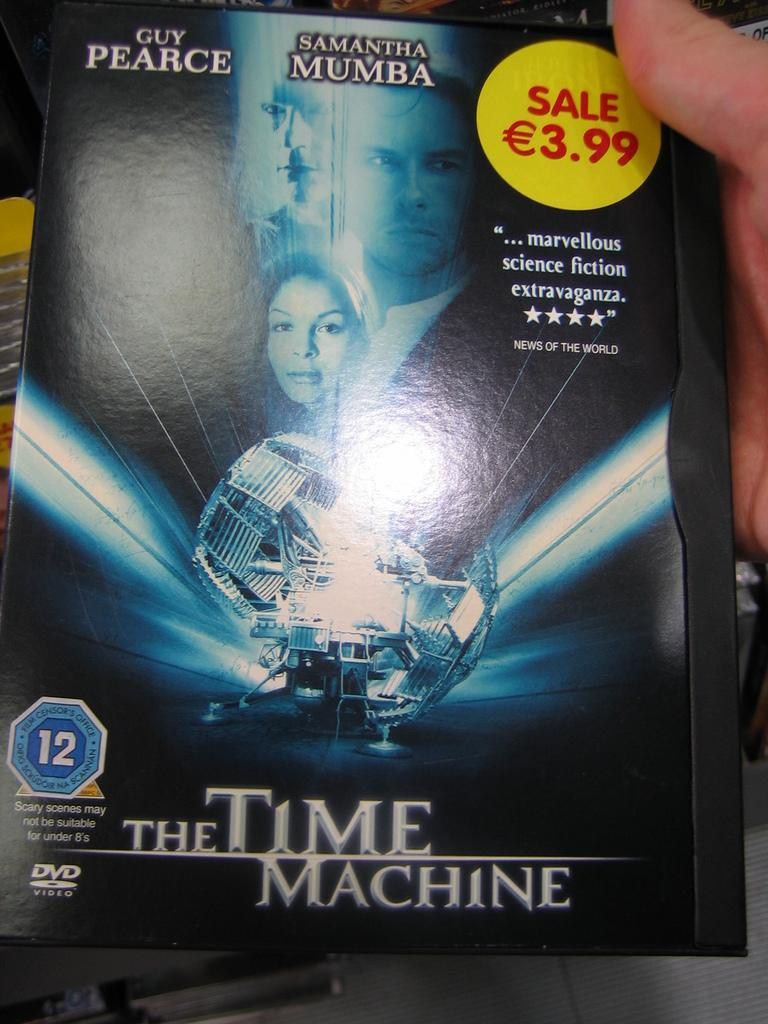Provide a one-sentence caption for the provided image. The DVD movie The Time Machine and stars Samantha Mumba. 